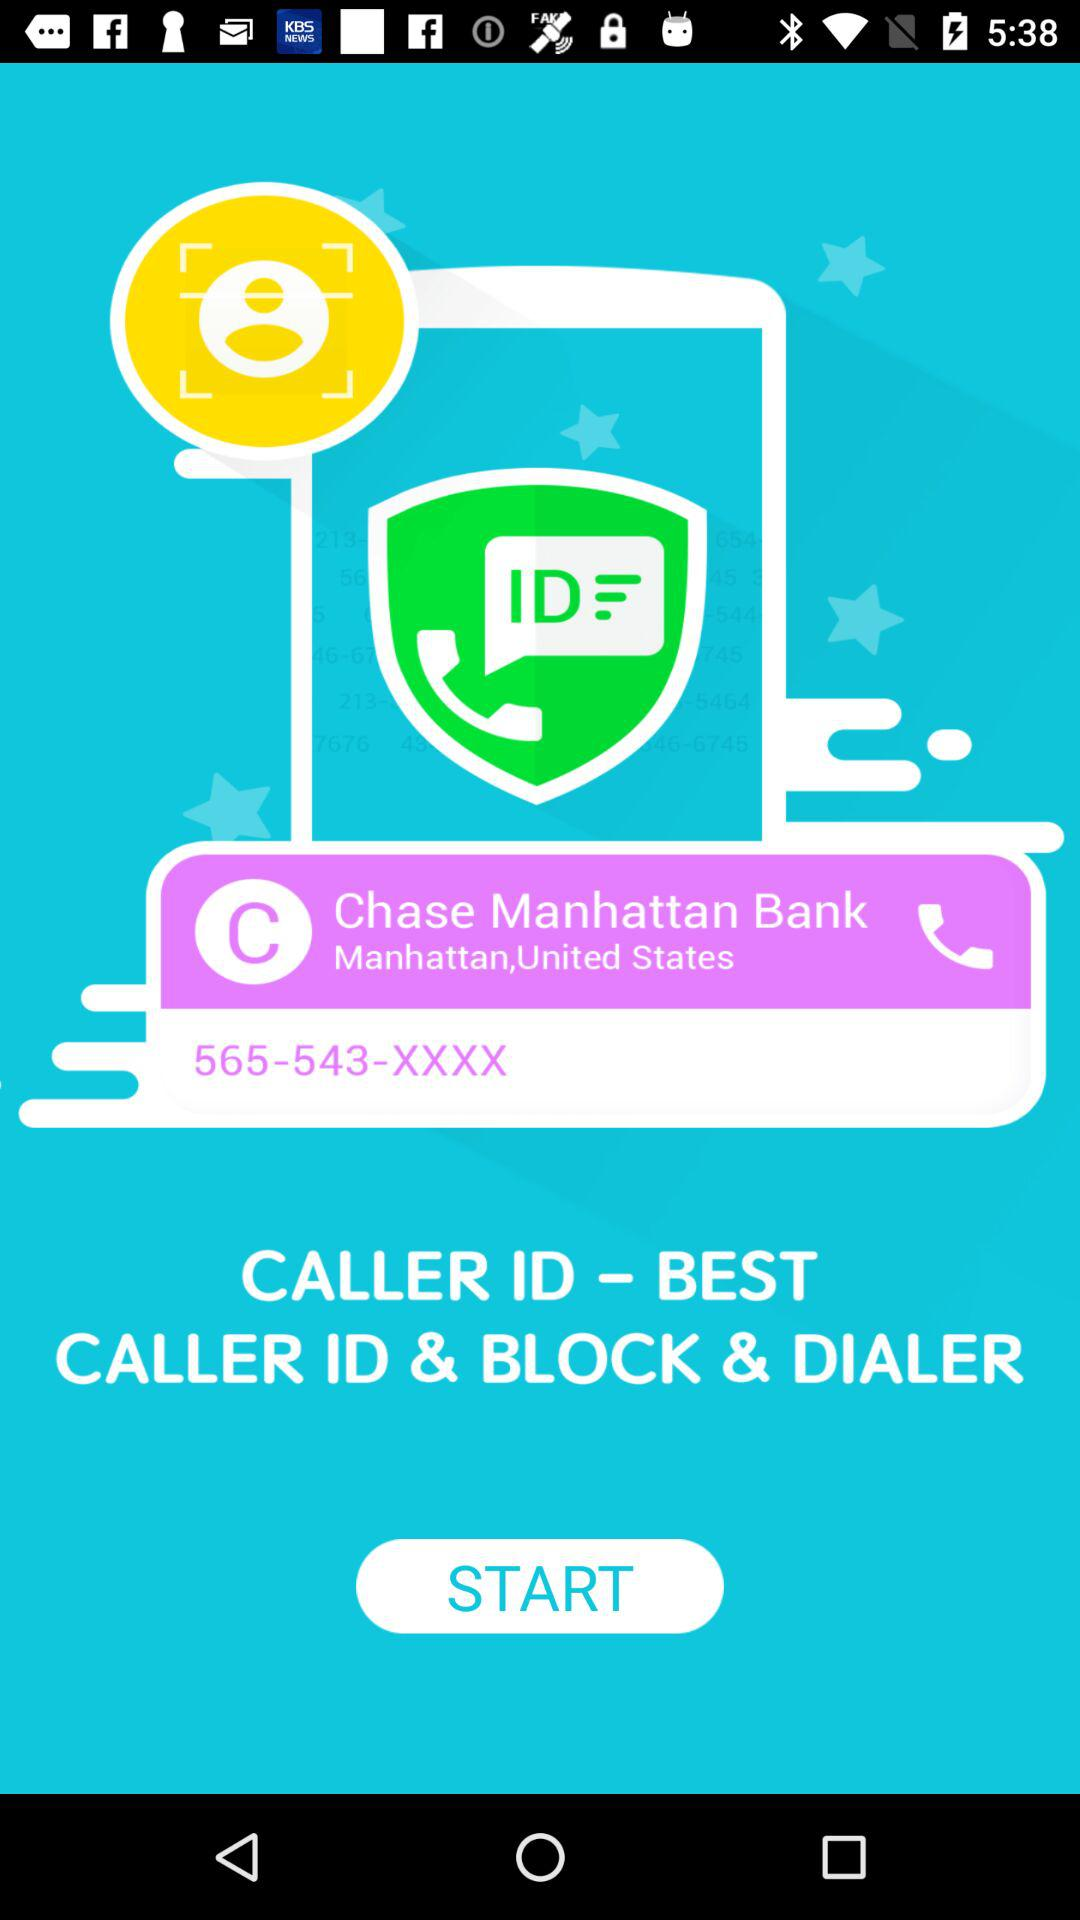What is the location of the bank? The location of the bank is Manhattan, United States. 